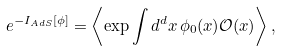Convert formula to latex. <formula><loc_0><loc_0><loc_500><loc_500>\ e ^ { - I _ { A d S } [ \phi ] } = \left \langle \exp \int d ^ { d } x \, \phi _ { 0 } ( x ) \mathcal { O } ( x ) \right \rangle ,</formula> 